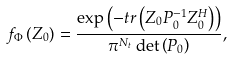<formula> <loc_0><loc_0><loc_500><loc_500>f _ { \Phi } \left ( Z _ { 0 } \right ) = \frac { \exp \left ( - t r \left ( Z _ { 0 } P _ { 0 } ^ { - 1 } Z _ { 0 } ^ { H } \right ) \right ) } { \pi ^ { N _ { t } } \det \left ( P _ { 0 } \right ) } ,</formula> 